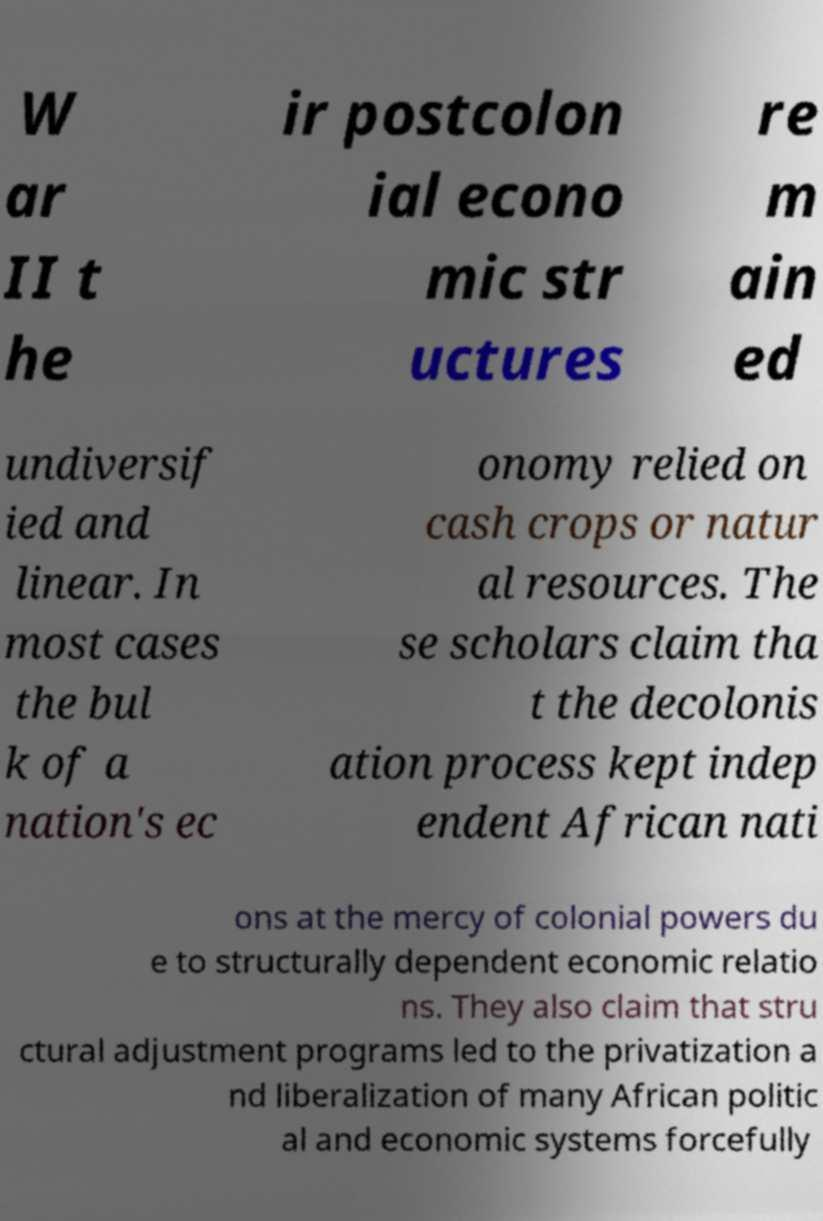What messages or text are displayed in this image? I need them in a readable, typed format. W ar II t he ir postcolon ial econo mic str uctures re m ain ed undiversif ied and linear. In most cases the bul k of a nation's ec onomy relied on cash crops or natur al resources. The se scholars claim tha t the decolonis ation process kept indep endent African nati ons at the mercy of colonial powers du e to structurally dependent economic relatio ns. They also claim that stru ctural adjustment programs led to the privatization a nd liberalization of many African politic al and economic systems forcefully 